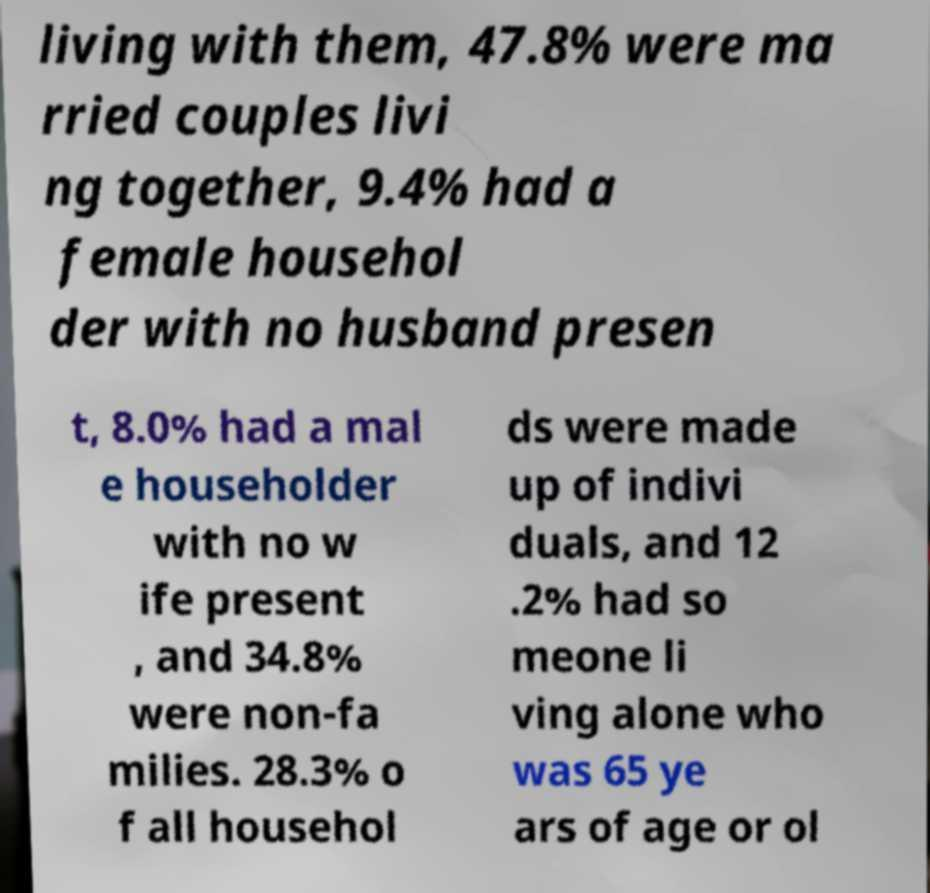For documentation purposes, I need the text within this image transcribed. Could you provide that? living with them, 47.8% were ma rried couples livi ng together, 9.4% had a female househol der with no husband presen t, 8.0% had a mal e householder with no w ife present , and 34.8% were non-fa milies. 28.3% o f all househol ds were made up of indivi duals, and 12 .2% had so meone li ving alone who was 65 ye ars of age or ol 